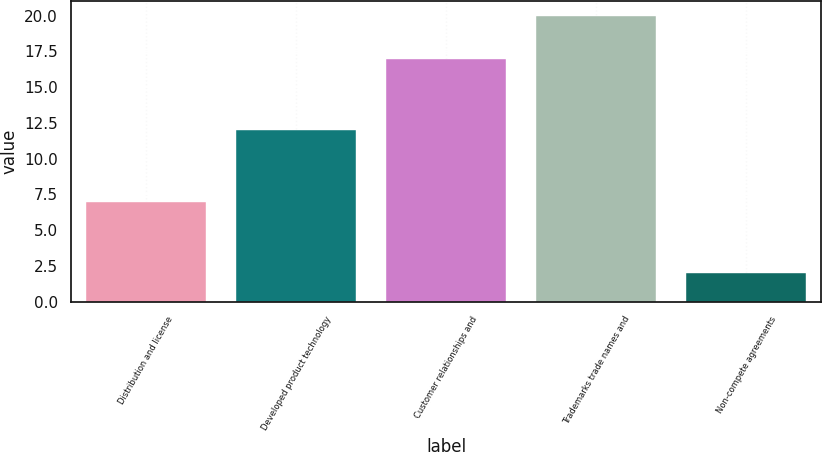<chart> <loc_0><loc_0><loc_500><loc_500><bar_chart><fcel>Distribution and license<fcel>Developed product technology<fcel>Customer relationships and<fcel>Trademarks trade names and<fcel>Non-compete agreements<nl><fcel>7<fcel>12<fcel>17<fcel>20<fcel>2<nl></chart> 